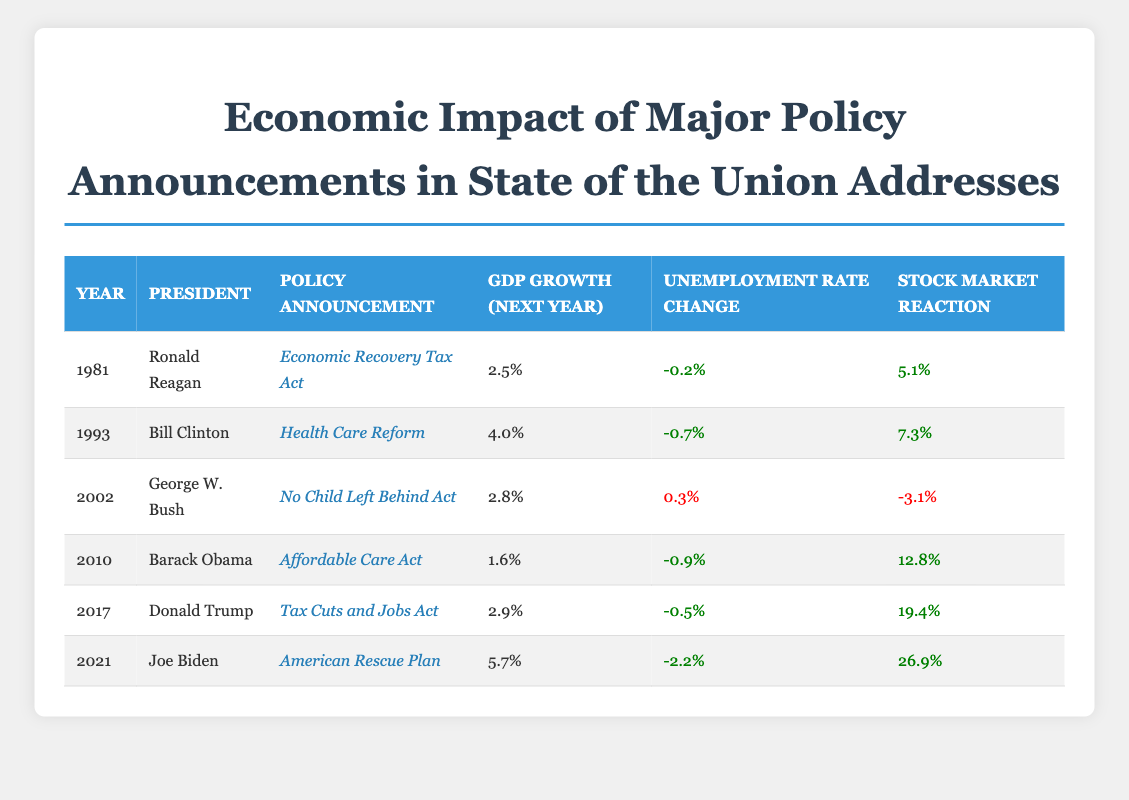What was the GDP growth the year after Barack Obama announced the Affordable Care Act? The table shows that for the year 2010, when Barack Obama announced the Affordable Care Act, the GDP growth for the next year was 1.6%.
Answer: 1.6% Which president had the highest stock market reaction following a policy announcement? By examining the stock market reactions in the table, Joe Biden's American Rescue Plan announced in 2021 saw the highest stock market reaction of 26.9%.
Answer: Joe Biden Did the unemployment rate change positively for all policy announcements? Looking at the table, we see that the unemployment rate changed positively (decrease) in most cases, but for the No Child Left Behind Act announced in 2002, the change was negative (0.3%).
Answer: No What was the average GDP growth for the years listed in the table? To find the average GDP growth, we sum the GDP growth values: 2.5 + 4.0 + 2.8 + 1.6 + 2.9 + 5.7 = 19.5. There are 6 data points, so the average GDP growth is 19.5 / 6 = 3.25%.
Answer: 3.25% In which year did the announcement result in the largest reduction in unemployment rate? By comparing the unemployment rate changes, we find that Joe Biden's announcement in 2021 led to the largest reduction of -2.2%.
Answer: 2021 What was the difference in stock market reaction between Bill Clinton's Health Care Reform and George W. Bush's No Child Left Behind Act? From the table, Bill Clinton's Health Care Reform had a stock market reaction of 7.3%, while George W. Bush's No Child Left Behind Act had a reaction of -3.1%. The difference is 7.3 - (-3.1) = 10.4%.
Answer: 10.4% Was the stock market reaction for Donald Trump's Tax Cuts and Jobs Act higher than that for Barack Obama's Affordable Care Act? The table shows Donald Trump's stock market reaction was 19.4% and Barack Obama's was 12.8%, indicating that Trump's reaction was indeed higher.
Answer: Yes Which policy announcement had the most significant positive influence on GDP growth the following year? The highest GDP growth next year was for Joe Biden's American Rescue Plan with 5.7%, making it the most significant growth.
Answer: 5.7% 